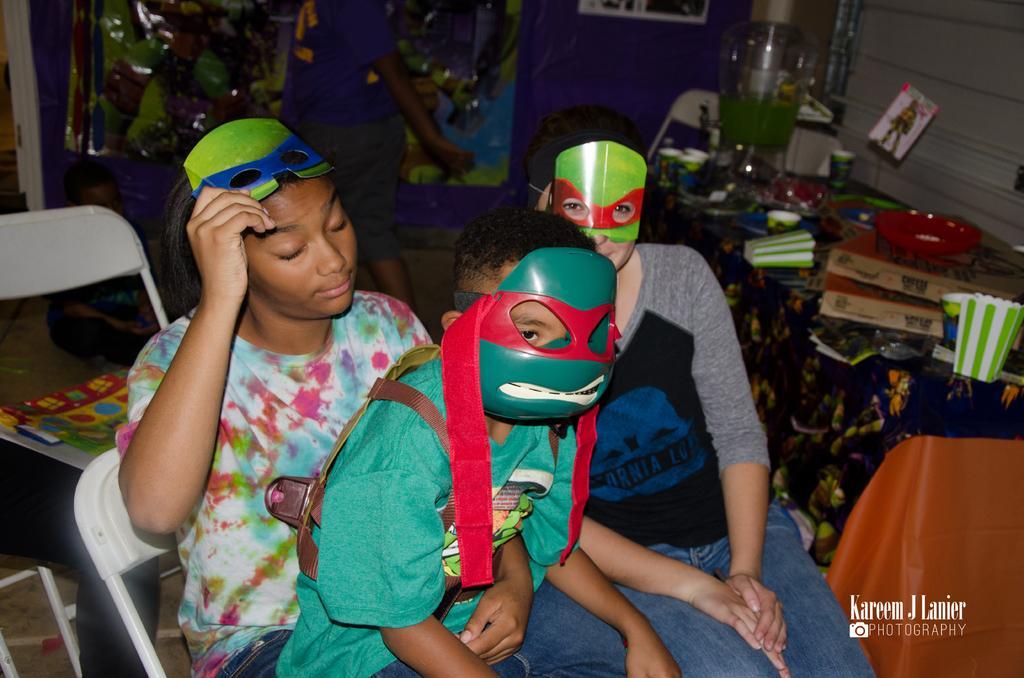Please provide a concise description of this image. In this image three people were sitting on the chair. At the right side of the image there is a table and on top of it there is a water bottle, plate and few other objects. Beside the table there is a chair and at the background there is a banner. 